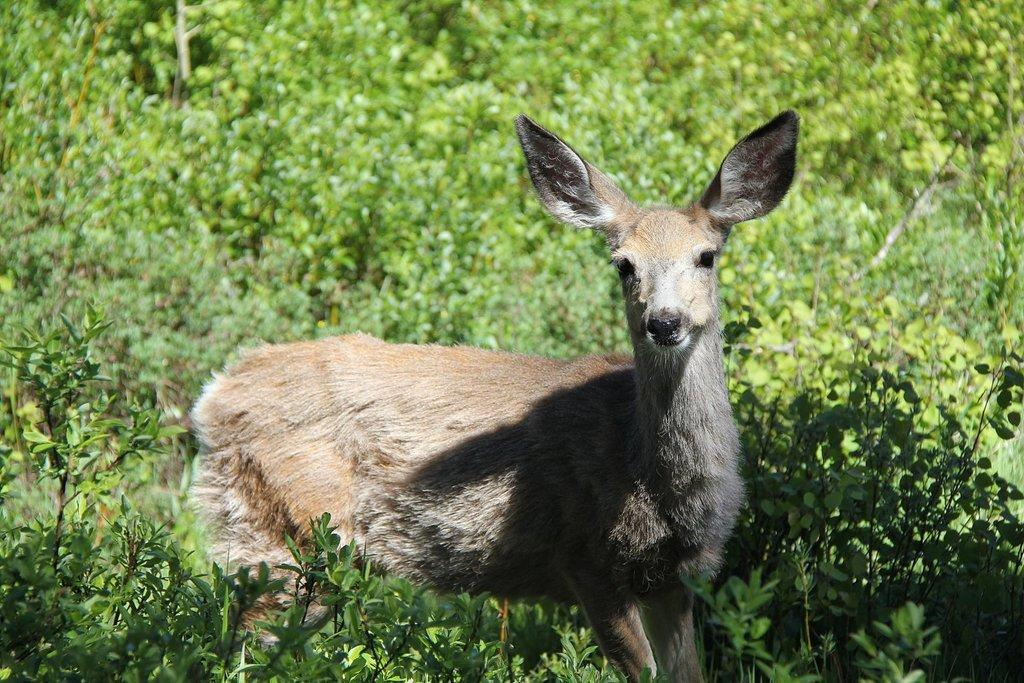What type of animal is in the image? There is a deer in the image. What else can be seen in the image besides the deer? There are plants in the image. What question is the deer asking in the image? There is no indication in the image that the deer is asking a question, as animals do not communicate through language in the same way humans do. 